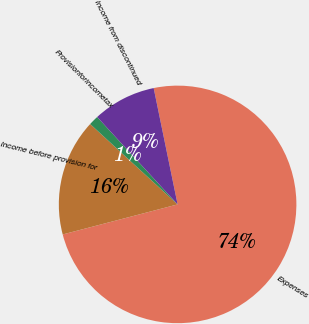Convert chart to OTSL. <chart><loc_0><loc_0><loc_500><loc_500><pie_chart><fcel>Expenses<fcel>Income before provision for<fcel>Provisionforincometax<fcel>Income from discontinued<nl><fcel>74.16%<fcel>15.9%<fcel>1.33%<fcel>8.61%<nl></chart> 